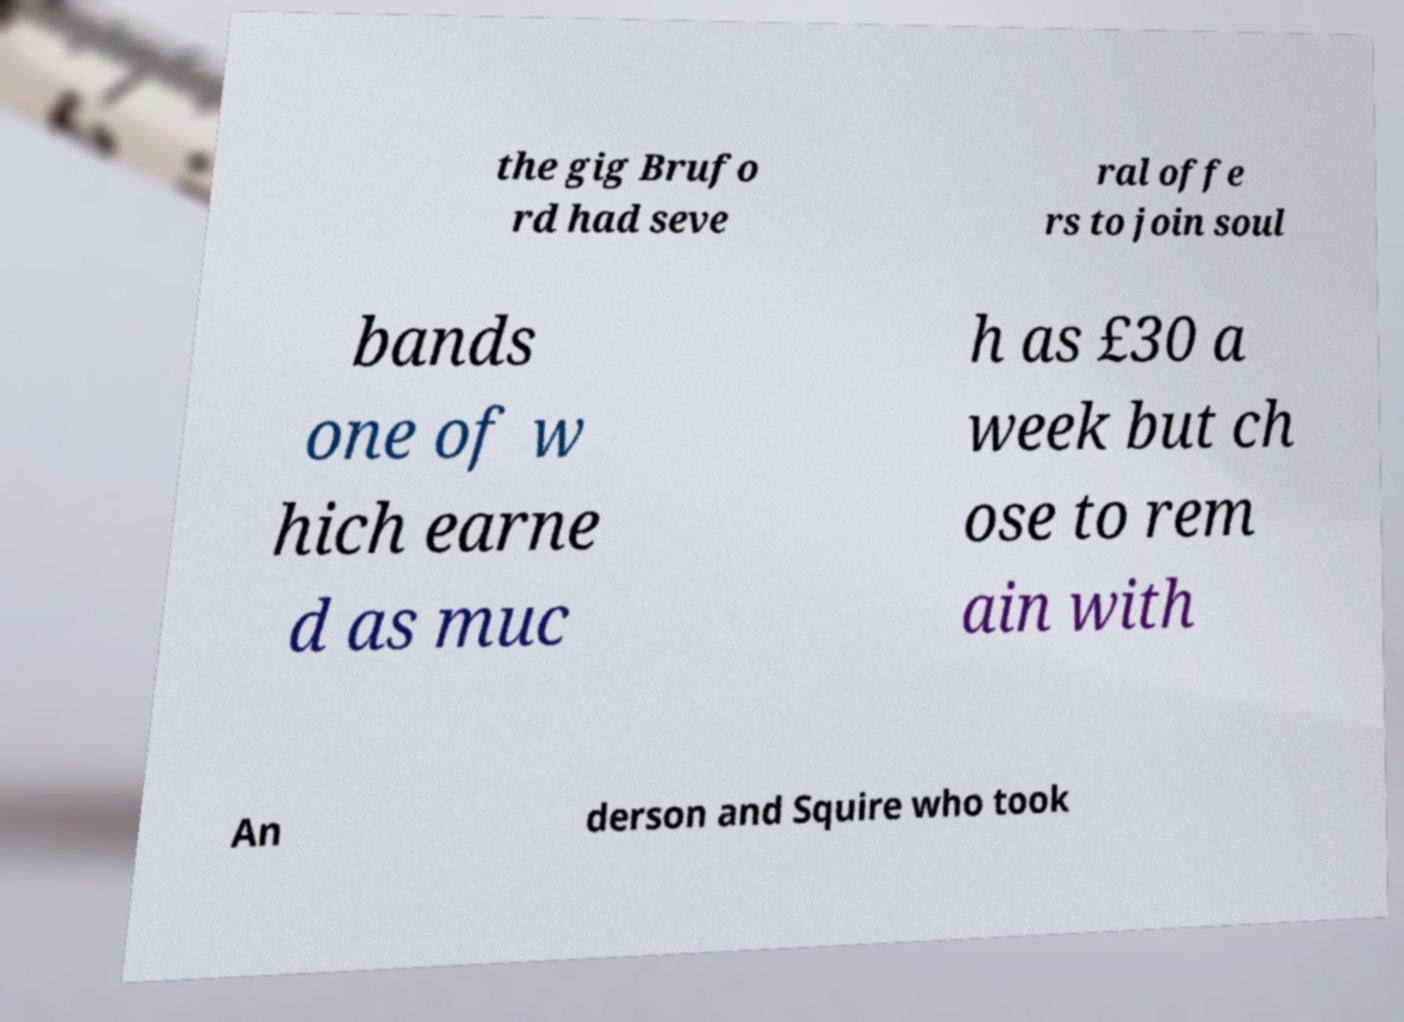What messages or text are displayed in this image? I need them in a readable, typed format. the gig Brufo rd had seve ral offe rs to join soul bands one of w hich earne d as muc h as £30 a week but ch ose to rem ain with An derson and Squire who took 